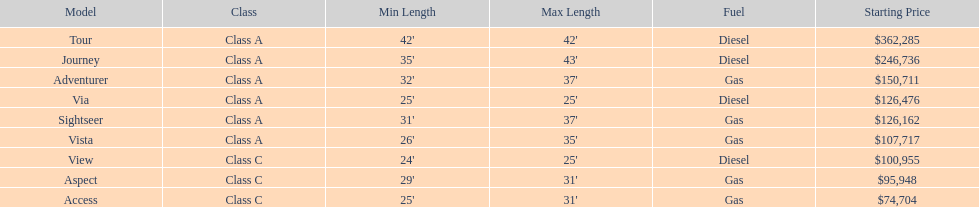Which model is at the top of the list with the highest starting price? Tour. 